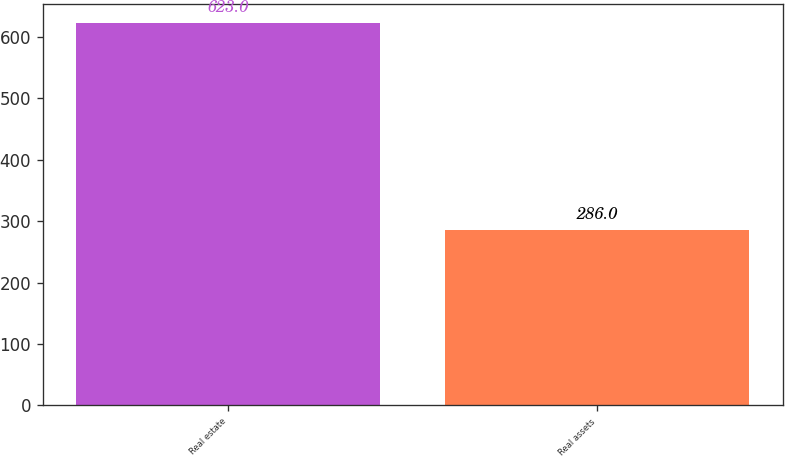<chart> <loc_0><loc_0><loc_500><loc_500><bar_chart><fcel>Real estate<fcel>Real assets<nl><fcel>623<fcel>286<nl></chart> 